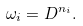<formula> <loc_0><loc_0><loc_500><loc_500>\omega _ { i } = D ^ { n _ { i } } .</formula> 